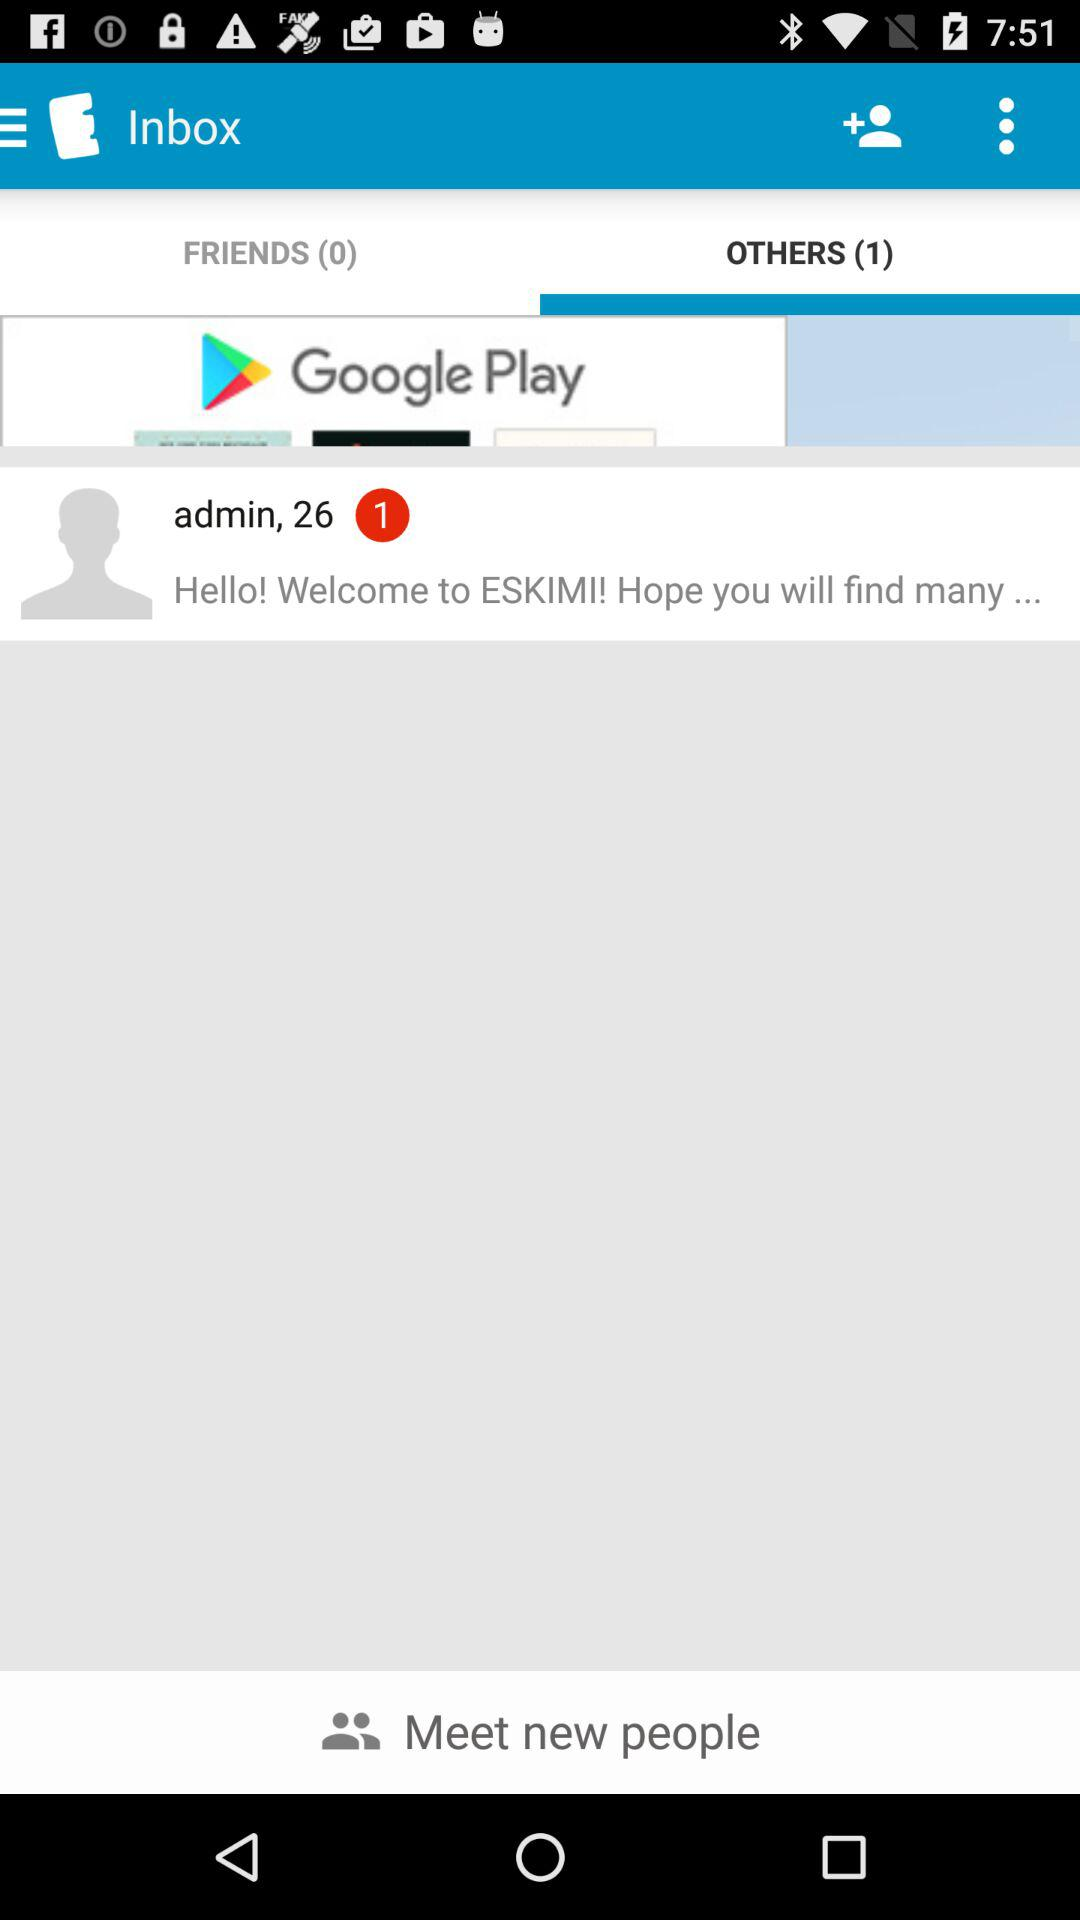How many friends are there? There are 0 friends. 